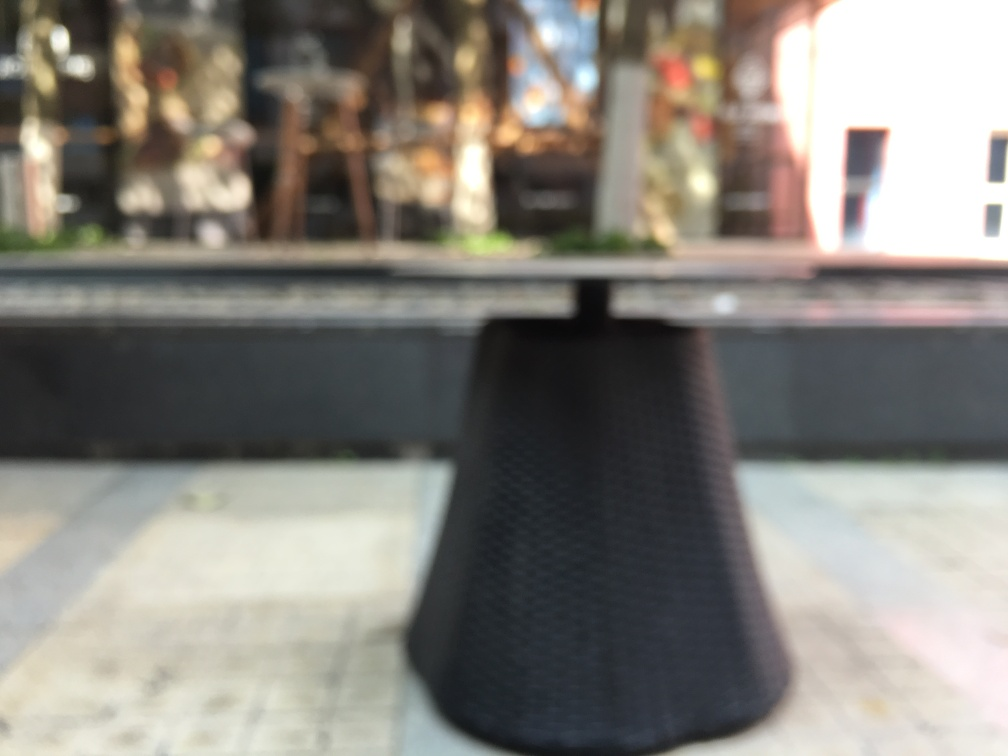What could be the reason for this image being blurred? The blurriness of the image could be due to a shallow depth of field used during photography, where only a specific distance range is in focus, or it might be intentionally applied in post-processing for artistic effect. It's also possible that it's simply an out-of-focus shot due to camera movement or an error in setting the focus point. 